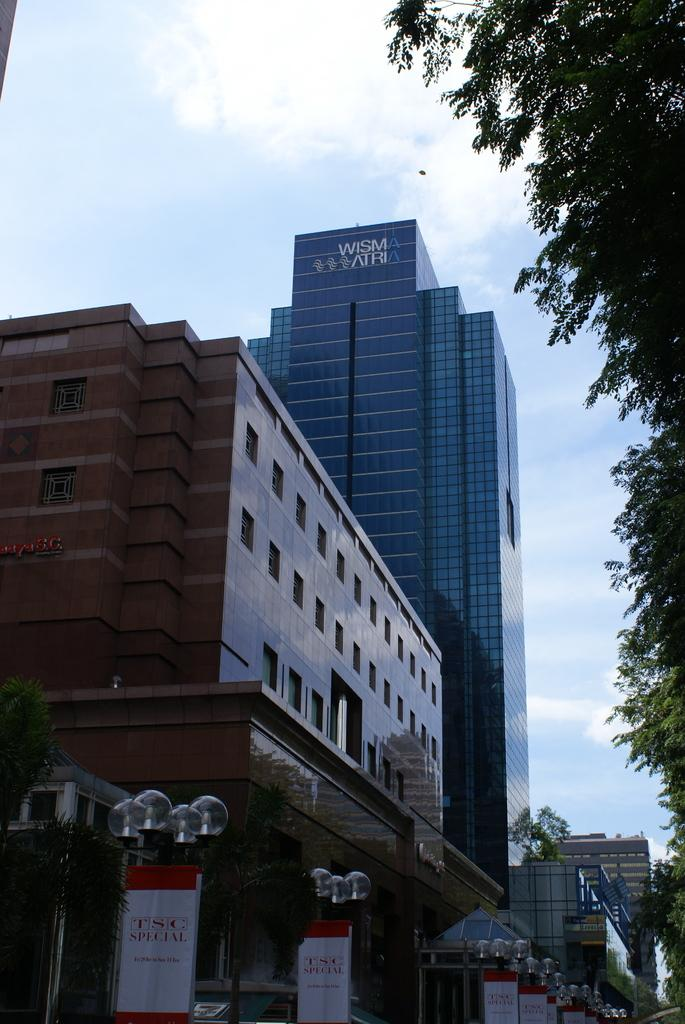<image>
Create a compact narrative representing the image presented. Various building one taller one says WISMA ATRIA 